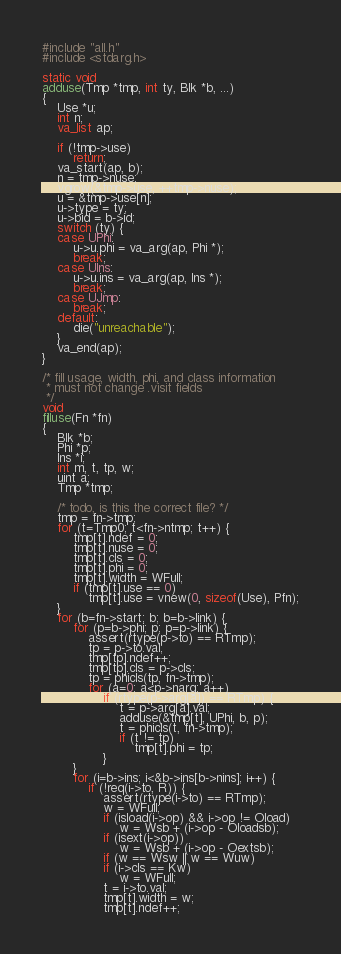Convert code to text. <code><loc_0><loc_0><loc_500><loc_500><_C_>#include "all.h"
#include <stdarg.h>

static void
adduse(Tmp *tmp, int ty, Blk *b, ...)
{
	Use *u;
	int n;
	va_list ap;

	if (!tmp->use)
		return;
	va_start(ap, b);
	n = tmp->nuse;
	vgrow(&tmp->use, ++tmp->nuse);
	u = &tmp->use[n];
	u->type = ty;
	u->bid = b->id;
	switch (ty) {
	case UPhi:
		u->u.phi = va_arg(ap, Phi *);
		break;
	case UIns:
		u->u.ins = va_arg(ap, Ins *);
		break;
	case UJmp:
		break;
	default:
		die("unreachable");
	}
	va_end(ap);
}

/* fill usage, width, phi, and class information
 * must not change .visit fields
 */
void
filluse(Fn *fn)
{
	Blk *b;
	Phi *p;
	Ins *i;
	int m, t, tp, w;
	uint a;
	Tmp *tmp;

	/* todo, is this the correct file? */
	tmp = fn->tmp;
	for (t=Tmp0; t<fn->ntmp; t++) {
		tmp[t].ndef = 0;
		tmp[t].nuse = 0;
		tmp[t].cls = 0;
		tmp[t].phi = 0;
		tmp[t].width = WFull;
		if (tmp[t].use == 0)
			tmp[t].use = vnew(0, sizeof(Use), Pfn);
	}
	for (b=fn->start; b; b=b->link) {
		for (p=b->phi; p; p=p->link) {
			assert(rtype(p->to) == RTmp);
			tp = p->to.val;
			tmp[tp].ndef++;
			tmp[tp].cls = p->cls;
			tp = phicls(tp, fn->tmp);
			for (a=0; a<p->narg; a++)
				if (rtype(p->arg[a]) == RTmp) {
					t = p->arg[a].val;
					adduse(&tmp[t], UPhi, b, p);
					t = phicls(t, fn->tmp);
					if (t != tp)
						tmp[t].phi = tp;
				}
		}
		for (i=b->ins; i<&b->ins[b->nins]; i++) {
			if (!req(i->to, R)) {
				assert(rtype(i->to) == RTmp);
				w = WFull;
				if (isload(i->op) && i->op != Oload)
					w = Wsb + (i->op - Oloadsb);
				if (isext(i->op))
					w = Wsb + (i->op - Oextsb);
				if (w == Wsw || w == Wuw)
				if (i->cls == Kw)
					w = WFull;
				t = i->to.val;
				tmp[t].width = w;
				tmp[t].ndef++;</code> 